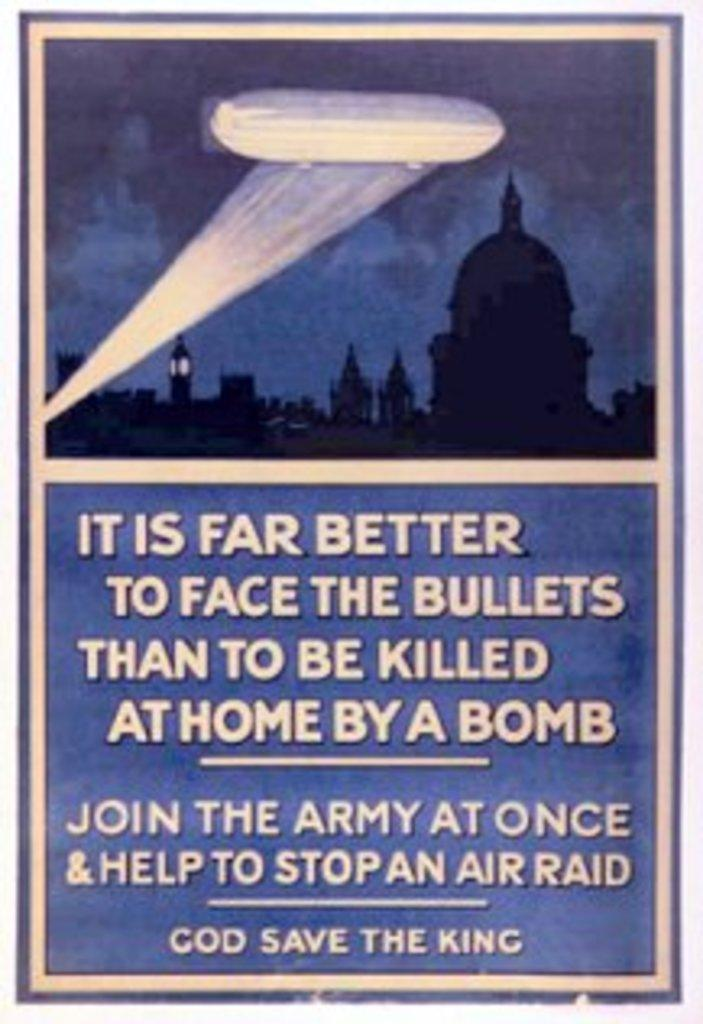<image>
Summarize the visual content of the image. a paper that says 'God save the king' on the bottom 